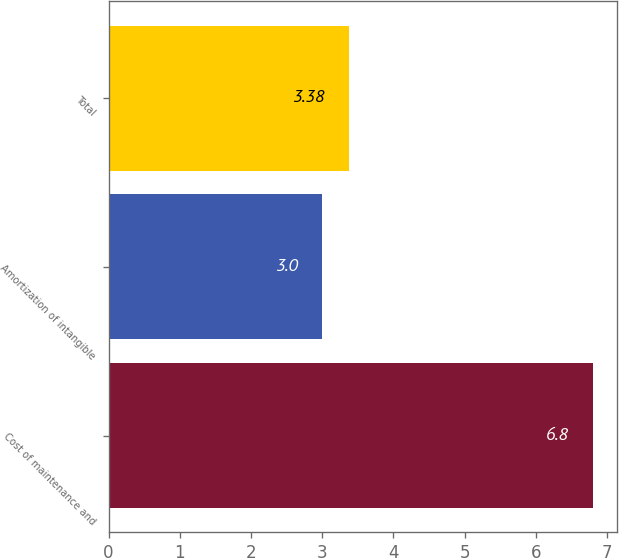Convert chart. <chart><loc_0><loc_0><loc_500><loc_500><bar_chart><fcel>Cost of maintenance and<fcel>Amortization of intangible<fcel>Total<nl><fcel>6.8<fcel>3<fcel>3.38<nl></chart> 